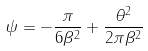<formula> <loc_0><loc_0><loc_500><loc_500>\psi = - \frac { \pi } { 6 \beta ^ { 2 } } + \frac { \theta ^ { 2 } } { 2 \pi \beta ^ { 2 } }</formula> 